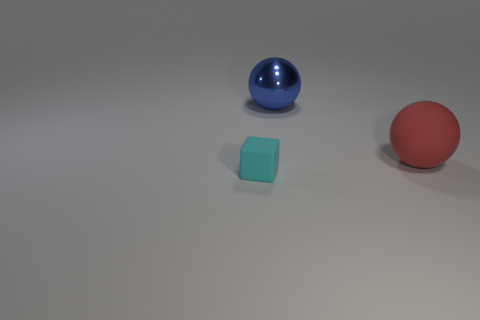What color is the small rubber thing?
Your answer should be very brief. Cyan. What number of things are both behind the cyan thing and in front of the big blue metallic thing?
Provide a succinct answer. 1. Is the number of rubber objects behind the tiny block the same as the number of big matte spheres that are to the left of the big red matte ball?
Give a very brief answer. No. There is a matte thing behind the small cube; is it the same shape as the cyan rubber object?
Offer a very short reply. No. What shape is the rubber thing behind the rubber object to the left of the big thing in front of the blue metallic thing?
Your answer should be very brief. Sphere. There is a object that is both to the right of the cyan object and left of the big red matte thing; what is it made of?
Give a very brief answer. Metal. Is the number of tiny gray matte blocks less than the number of big blue things?
Keep it short and to the point. Yes. Do the tiny rubber thing and the rubber object that is to the right of the tiny cyan rubber object have the same shape?
Your response must be concise. No. There is a sphere that is in front of the blue sphere; does it have the same size as the large shiny ball?
Keep it short and to the point. Yes. There is a rubber object that is the same size as the blue metallic thing; what shape is it?
Offer a very short reply. Sphere. 